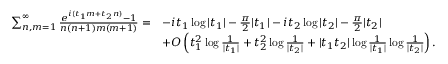Convert formula to latex. <formula><loc_0><loc_0><loc_500><loc_500>\begin{array} { r l } { \sum _ { n , m = 1 } ^ { \infty } \frac { e ^ { i ( t _ { 1 } m + t _ { 2 } n ) } - 1 } { n ( n + 1 ) m ( m + 1 ) } = } & { - i t _ { 1 } \log | t _ { 1 } | - \frac { \pi } { 2 } | t _ { 1 } | - i t _ { 2 } \log | t _ { 2 } | - \frac { \pi } { 2 } | t _ { 2 } | } \\ & { + O \left ( t _ { 1 } ^ { 2 } \log \frac { 1 } { | t _ { 1 } | } + t _ { 2 } ^ { 2 } \log \frac { 1 } { | t _ { 2 } | } + | t _ { 1 } t _ { 2 } | \log \frac { 1 } { | t _ { 1 } | } \log \frac { 1 } { | t _ { 2 } | } \right ) . } \end{array}</formula> 